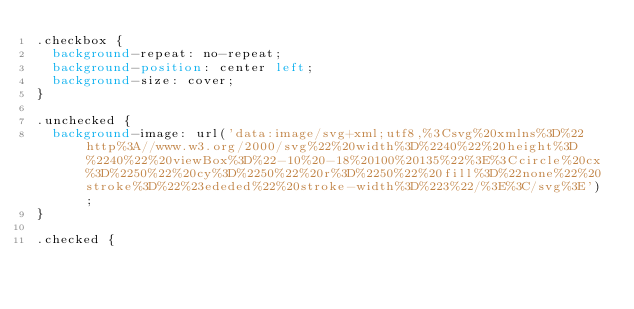Convert code to text. <code><loc_0><loc_0><loc_500><loc_500><_CSS_>.checkbox {
  background-repeat: no-repeat;
  background-position: center left;
  background-size: cover;
}

.unchecked {
  background-image: url('data:image/svg+xml;utf8,%3Csvg%20xmlns%3D%22http%3A//www.w3.org/2000/svg%22%20width%3D%2240%22%20height%3D%2240%22%20viewBox%3D%22-10%20-18%20100%20135%22%3E%3Ccircle%20cx%3D%2250%22%20cy%3D%2250%22%20r%3D%2250%22%20fill%3D%22none%22%20stroke%3D%22%23ededed%22%20stroke-width%3D%223%22/%3E%3C/svg%3E');
}

.checked {</code> 